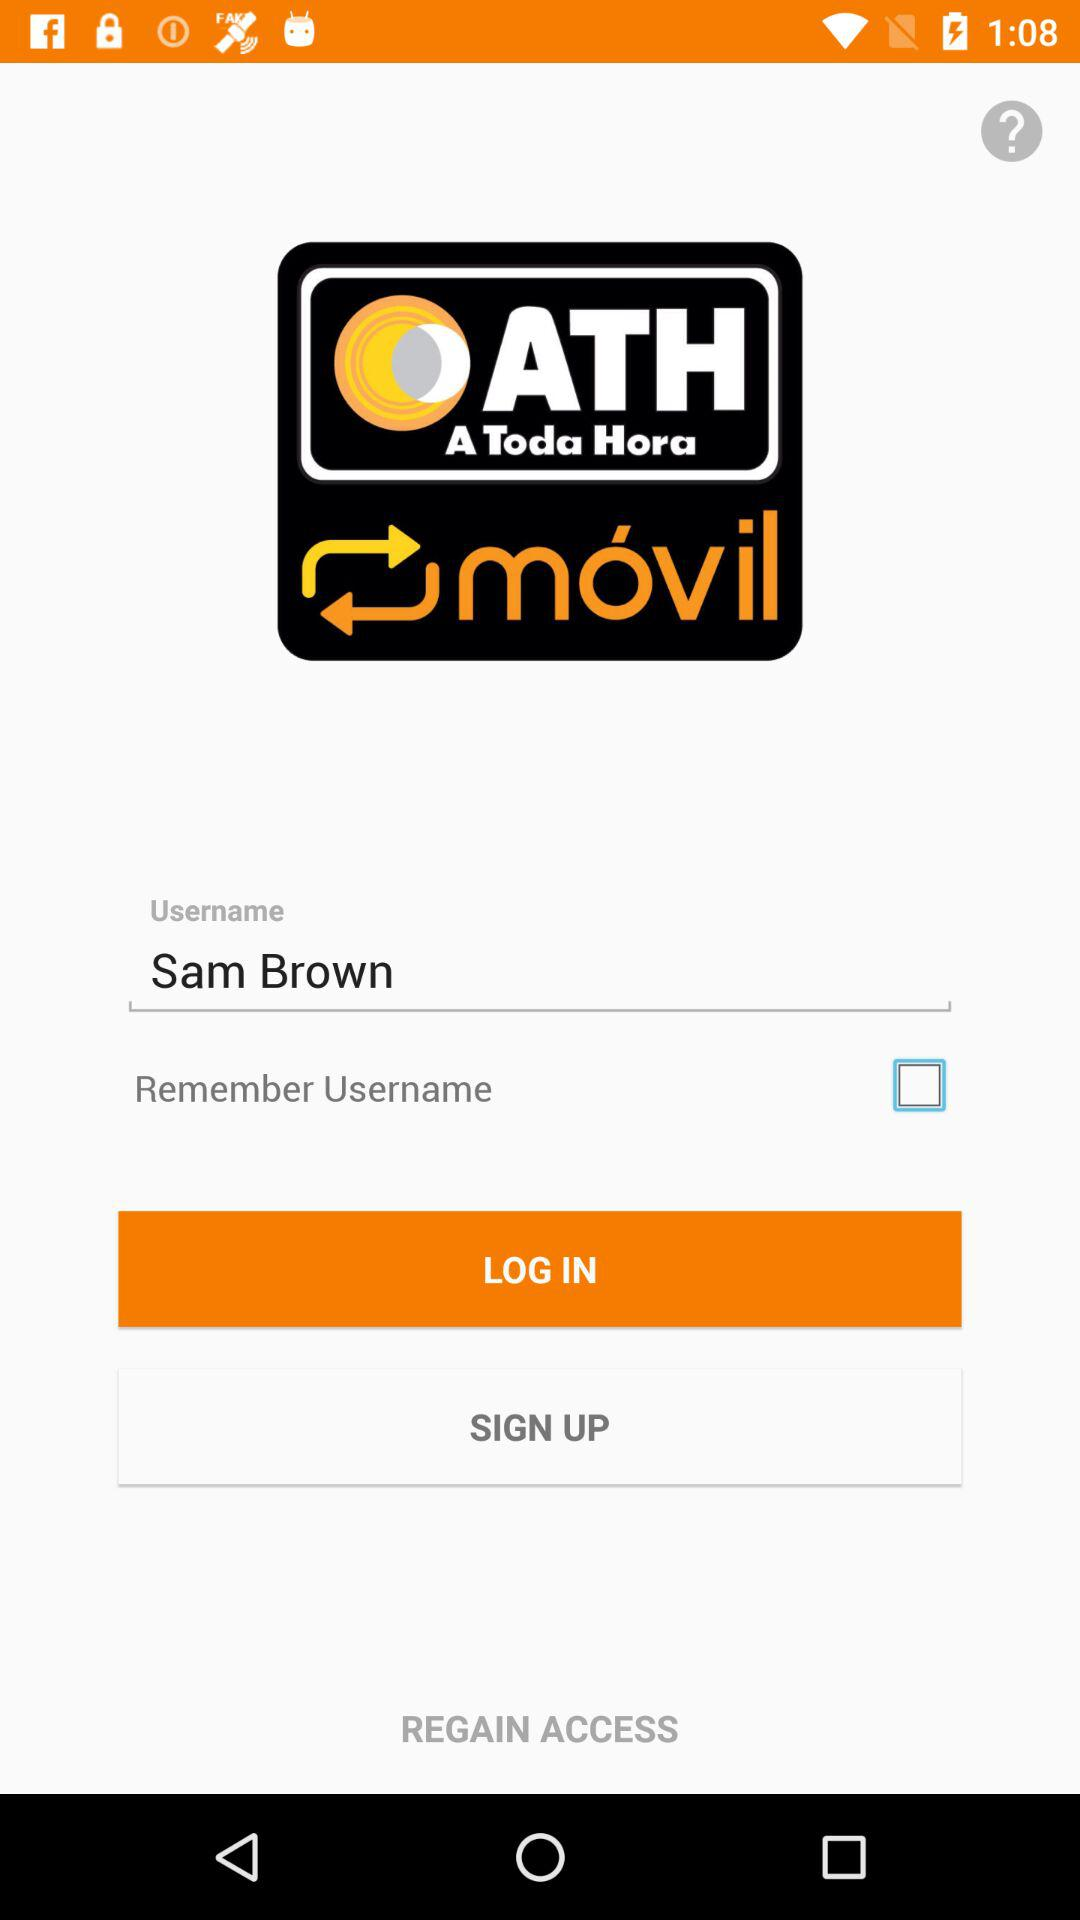What is the status of "Remember Username"? The status of "Remember Username" is "off". 